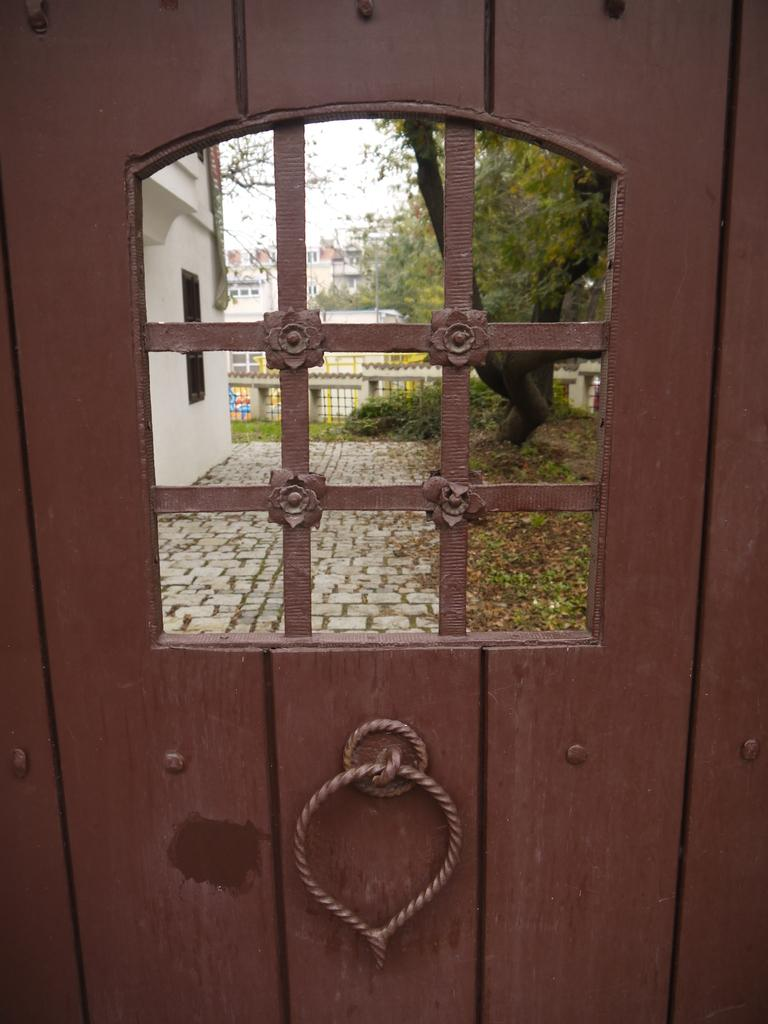What type of door is shown in the image? There is a wooden door in the image. What can be seen from the door? Buildings and trees are visible from the door. How does the sky look like from the door? The sky is visible from the door, and it appears to be cloudy. What is the chance of getting a hospital bed in the image? There is no mention of a hospital or hospital beds in the image, so it's not possible to determine the chance of getting a hospital bed. 